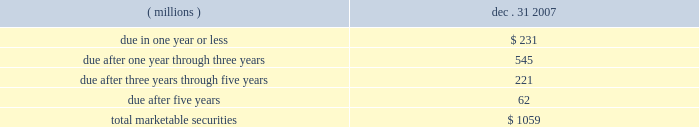28 , 35 , or 90 days .
The funds associated with failed auctions will not be accessible until a successful auction occurs or a buyer is found outside of the auction process .
Based on broker- dealer valuation models and an analysis of other-than-temporary impairment factors , auction rate securities with an original par value of approximately $ 34 million were written-down to an estimated fair value of $ 16 million as of december 31 , 2007 .
This write-down resulted in an 201cother-than-temporary 201d impairment charge of approximately $ 8 million ( pre-tax ) included in net income and a temporary impairment charge of $ 10 million ( pre-tax ) reflected as an unrealized loss within other comprehensive income for 2007 .
As of december 31 , 2007 , these investments in auction rate securities have been in a loss position for less than six months .
These auction rate securities are classified as non-current marketable securities as of december 31 , 2007 as indicated in the preceding table .
3m reviews impairments associated with the above in accordance with emerging issues task force ( eitf ) 03-1 and fsp sfas 115-1 and 124-1 , 201cthe meaning of other-than-temporary-impairment and its application to certain investments , 201d to determine the classification of the impairment as 201ctemporary 201d or 201cother-than-temporary . 201d a temporary impairment charge results in an unrealized loss being recorded in the other comprehensive income component of stockholders 2019 equity .
Such an unrealized loss does not reduce net income for the applicable accounting period because the loss is not viewed as other-than-temporary .
The company believes that a portion of the impairment of its auction rate securities investments is temporary and a portion is other-than-temporary .
The factors evaluated to differentiate between temporary and other-than-temporary include the projected future cash flows , credit ratings actions , and assessment of the credit quality of the underlying collateral .
The balance at december 31 , 2007 for marketable securities and short-term investments by contractual maturity are shown below .
Actual maturities may differ from contractual maturities because the issuers of the securities may have the right to prepay obligations without prepayment penalties .
Dec .
31 , ( millions ) 2007 .
Predetermined intervals , usually every 7 .
What is the percent of the securities due in one year or less to the total balance? 
Computations: (231 / 1059)
Answer: 0.21813. 